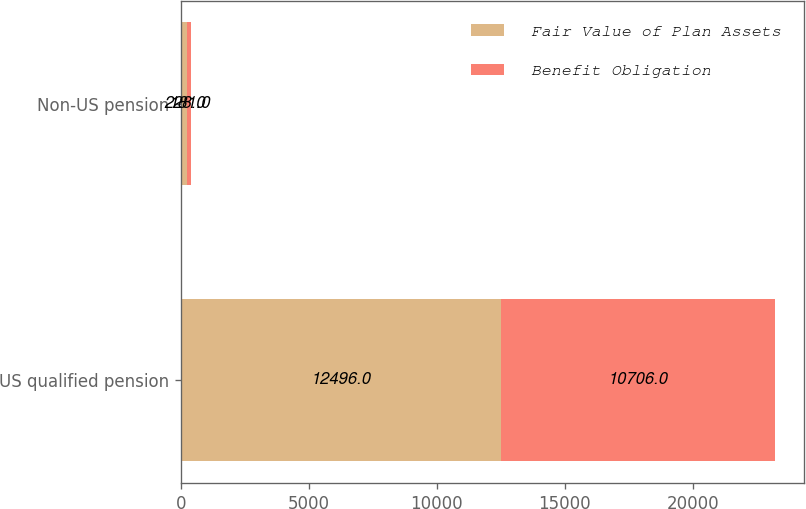<chart> <loc_0><loc_0><loc_500><loc_500><stacked_bar_chart><ecel><fcel>US qualified pension<fcel>Non-US pension<nl><fcel>Fair Value of Plan Assets<fcel>12496<fcel>228<nl><fcel>Benefit Obligation<fcel>10706<fcel>181<nl></chart> 